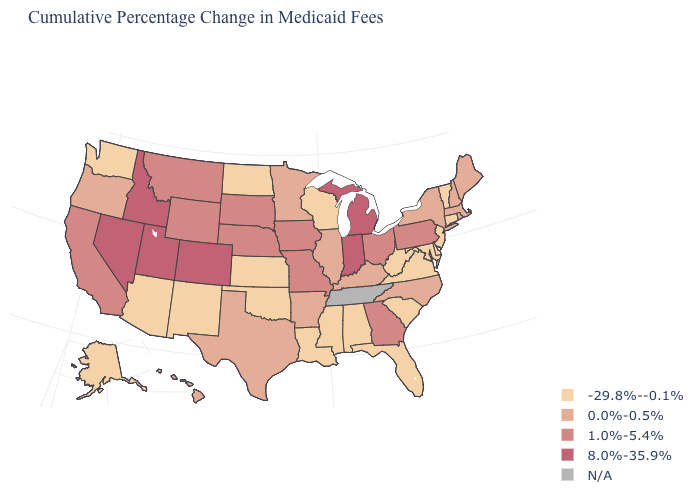How many symbols are there in the legend?
Concise answer only. 5. What is the value of Washington?
Write a very short answer. -29.8%--0.1%. What is the value of South Dakota?
Be succinct. 1.0%-5.4%. Among the states that border Michigan , which have the highest value?
Answer briefly. Indiana. Does South Dakota have the highest value in the MidWest?
Give a very brief answer. No. Name the states that have a value in the range N/A?
Be succinct. Tennessee. Which states have the lowest value in the West?
Give a very brief answer. Alaska, Arizona, New Mexico, Washington. Is the legend a continuous bar?
Give a very brief answer. No. Name the states that have a value in the range -29.8%--0.1%?
Be succinct. Alabama, Alaska, Arizona, Connecticut, Delaware, Florida, Kansas, Louisiana, Maryland, Mississippi, New Jersey, New Mexico, North Dakota, Oklahoma, South Carolina, Vermont, Virginia, Washington, West Virginia, Wisconsin. Does the first symbol in the legend represent the smallest category?
Concise answer only. Yes. Does New York have the lowest value in the Northeast?
Concise answer only. No. What is the value of Missouri?
Be succinct. 1.0%-5.4%. Name the states that have a value in the range 0.0%-0.5%?
Concise answer only. Arkansas, Hawaii, Illinois, Kentucky, Maine, Massachusetts, Minnesota, New Hampshire, New York, North Carolina, Oregon, Rhode Island, Texas. 